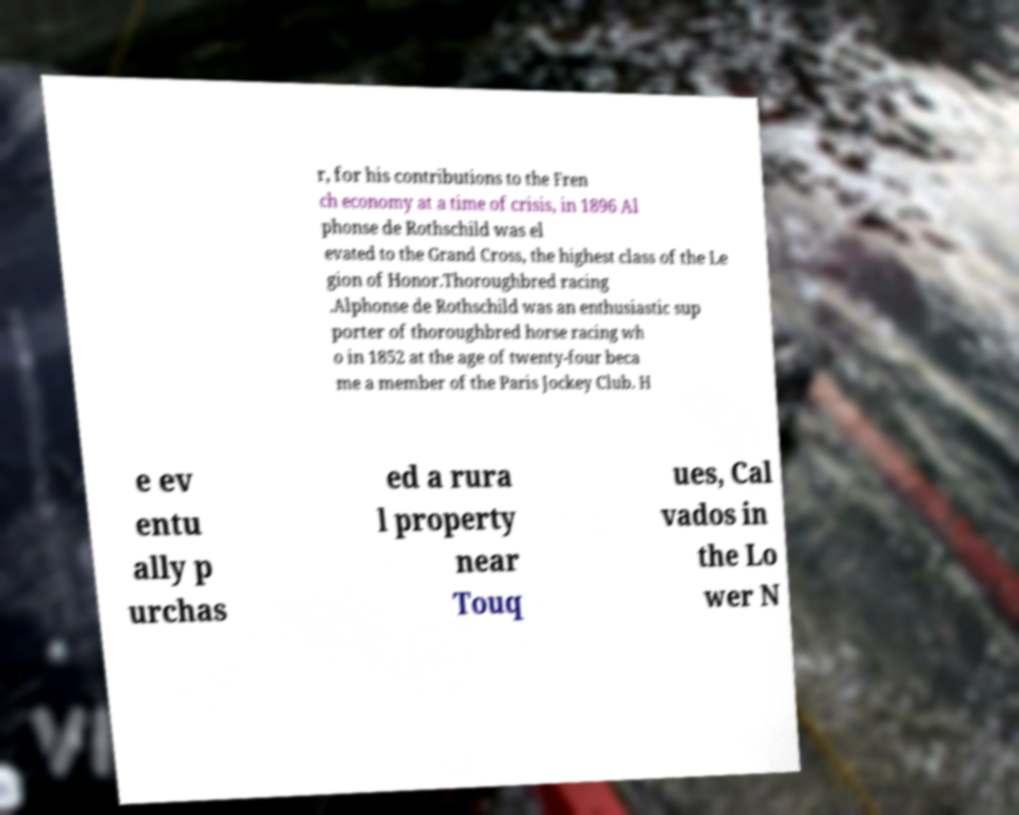I need the written content from this picture converted into text. Can you do that? r, for his contributions to the Fren ch economy at a time of crisis, in 1896 Al phonse de Rothschild was el evated to the Grand Cross, the highest class of the Le gion of Honor.Thoroughbred racing .Alphonse de Rothschild was an enthusiastic sup porter of thoroughbred horse racing wh o in 1852 at the age of twenty-four beca me a member of the Paris Jockey Club. H e ev entu ally p urchas ed a rura l property near Touq ues, Cal vados in the Lo wer N 